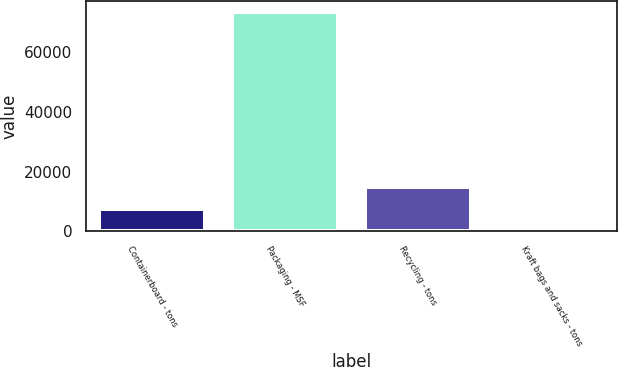Convert chart. <chart><loc_0><loc_0><loc_500><loc_500><bar_chart><fcel>Containerboard - tons<fcel>Packaging - MSF<fcel>Recycling - tons<fcel>Kraft bags and sacks - tons<nl><fcel>7443.2<fcel>73631<fcel>14797.4<fcel>89<nl></chart> 